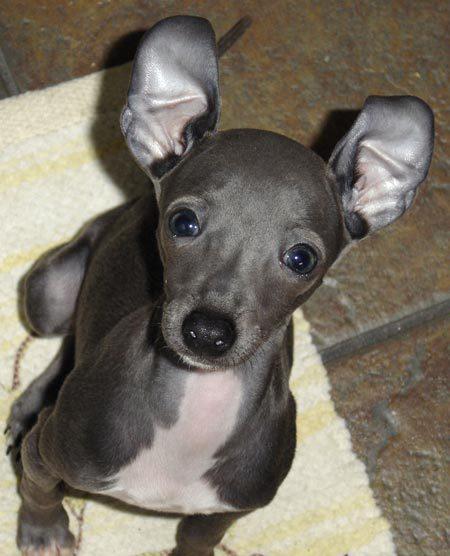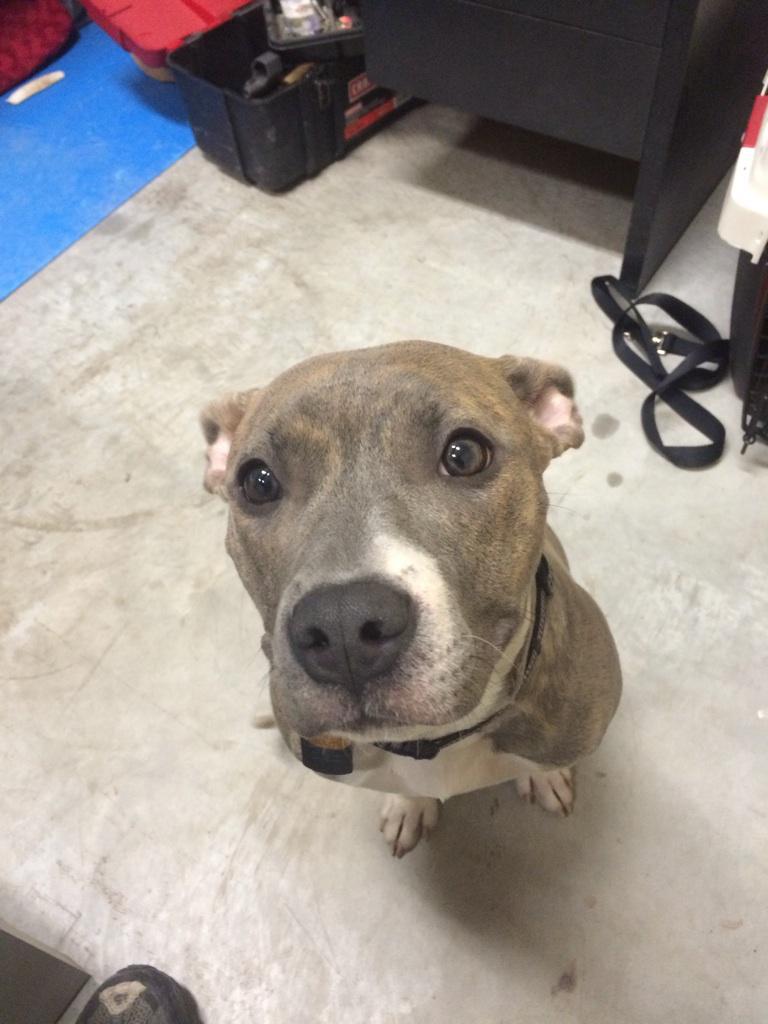The first image is the image on the left, the second image is the image on the right. Examine the images to the left and right. Is the description "Two dogs pose together in one of the pictures." accurate? Answer yes or no. No. The first image is the image on the left, the second image is the image on the right. Analyze the images presented: Is the assertion "An image contains two solid-colored hound dogs." valid? Answer yes or no. No. 